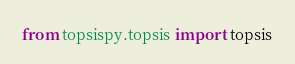<code> <loc_0><loc_0><loc_500><loc_500><_Python_>from topsispy.topsis import topsis</code> 